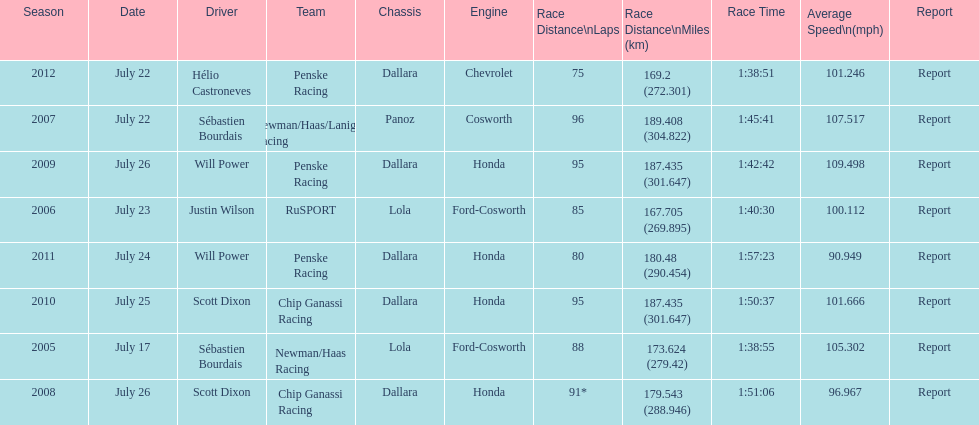Which team won the champ car world series the year before rusport? Newman/Haas Racing. 